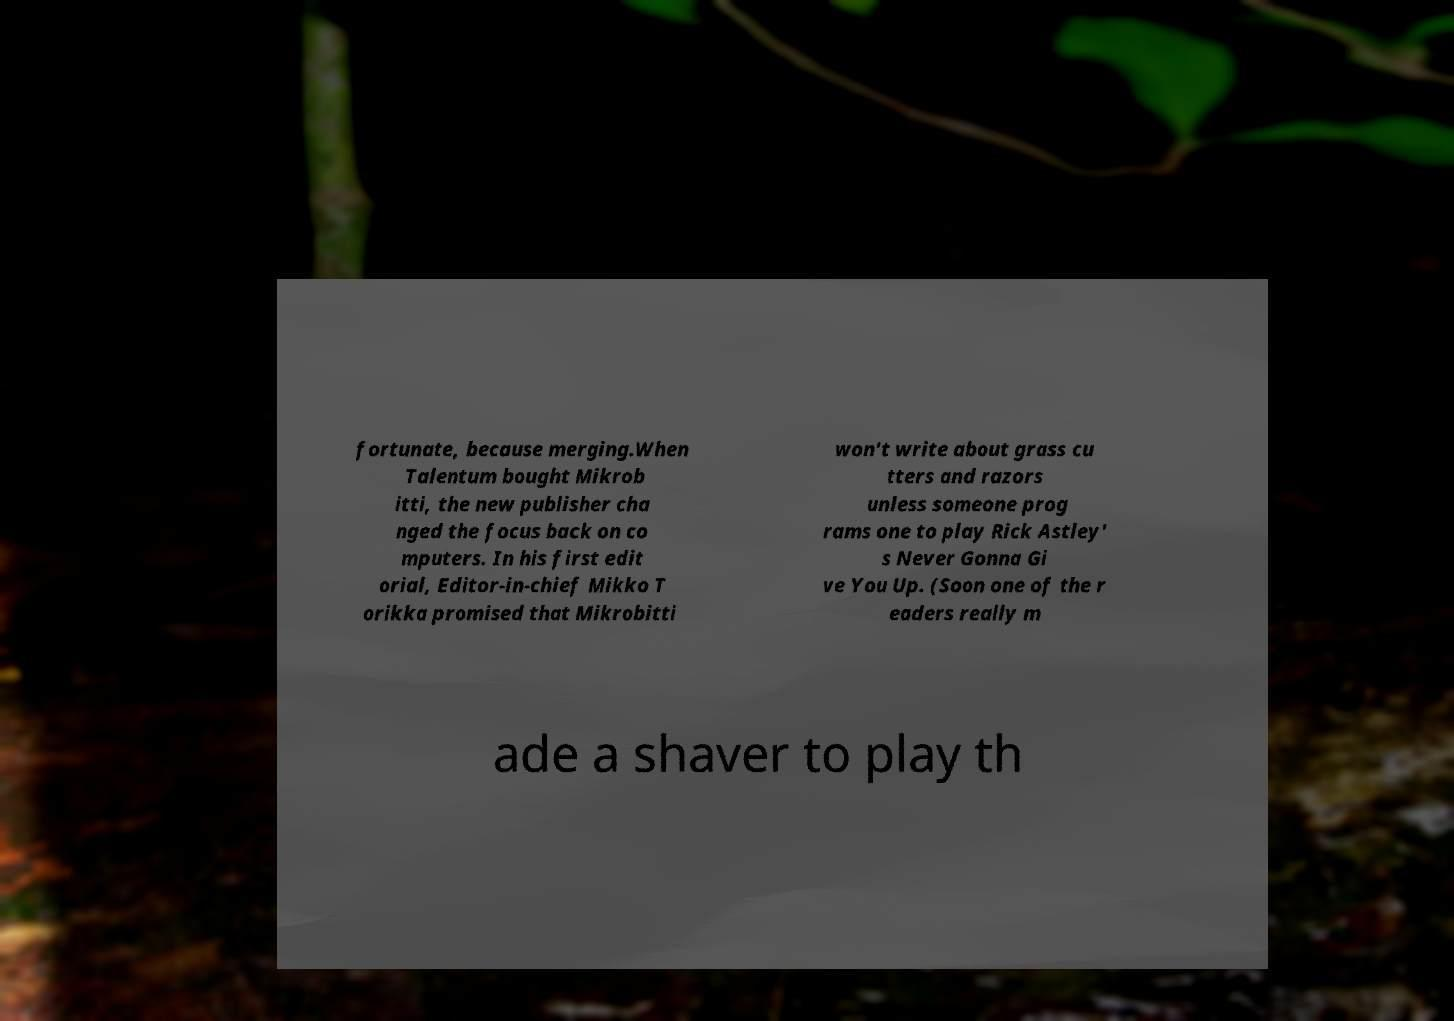Can you accurately transcribe the text from the provided image for me? fortunate, because merging.When Talentum bought Mikrob itti, the new publisher cha nged the focus back on co mputers. In his first edit orial, Editor-in-chief Mikko T orikka promised that Mikrobitti won't write about grass cu tters and razors unless someone prog rams one to play Rick Astley' s Never Gonna Gi ve You Up. (Soon one of the r eaders really m ade a shaver to play th 